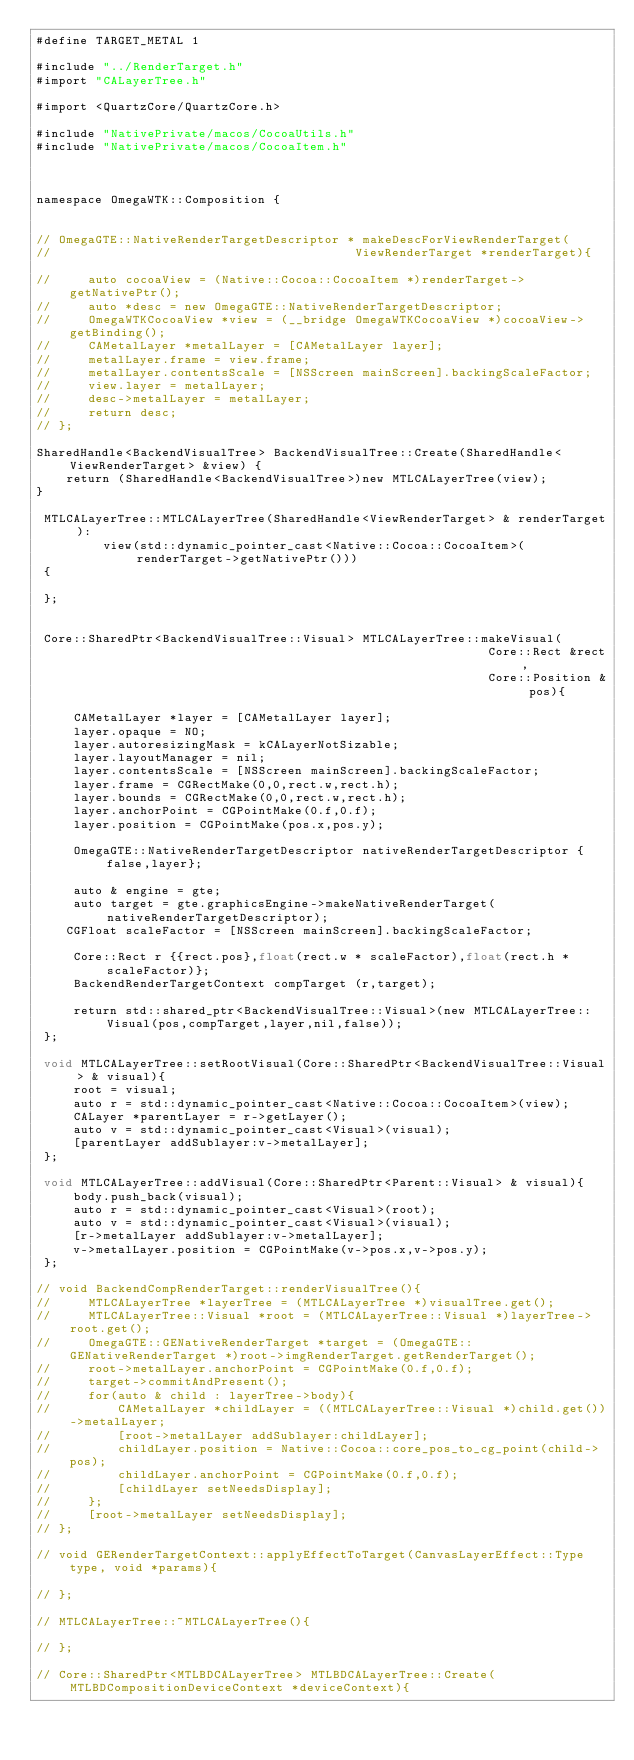<code> <loc_0><loc_0><loc_500><loc_500><_ObjectiveC_>#define TARGET_METAL 1

#include "../RenderTarget.h"
#import "CALayerTree.h"

#import <QuartzCore/QuartzCore.h>

#include "NativePrivate/macos/CocoaUtils.h"
#include "NativePrivate/macos/CocoaItem.h"



namespace OmegaWTK::Composition {


// OmegaGTE::NativeRenderTargetDescriptor * makeDescForViewRenderTarget(
//                                         ViewRenderTarget *renderTarget){

//     auto cocoaView = (Native::Cocoa::CocoaItem *)renderTarget->getNativePtr();
//     auto *desc = new OmegaGTE::NativeRenderTargetDescriptor;
//     OmegaWTKCocoaView *view = (__bridge OmegaWTKCocoaView *)cocoaView->getBinding();
//     CAMetalLayer *metalLayer = [CAMetalLayer layer];
//     metalLayer.frame = view.frame;
//     metalLayer.contentsScale = [NSScreen mainScreen].backingScaleFactor;
//     view.layer = metalLayer;
//     desc->metalLayer = metalLayer;
//     return desc;
// };

SharedHandle<BackendVisualTree> BackendVisualTree::Create(SharedHandle<ViewRenderTarget> &view) {
    return (SharedHandle<BackendVisualTree>)new MTLCALayerTree(view);
}

 MTLCALayerTree::MTLCALayerTree(SharedHandle<ViewRenderTarget> & renderTarget):
         view(std::dynamic_pointer_cast<Native::Cocoa::CocoaItem>(renderTarget->getNativePtr()))
 {

 };


 Core::SharedPtr<BackendVisualTree::Visual> MTLCALayerTree::makeVisual(
                                                             Core::Rect &rect,
                                                             Core::Position & pos){

     CAMetalLayer *layer = [CAMetalLayer layer];
     layer.opaque = NO;
     layer.autoresizingMask = kCALayerNotSizable;
     layer.layoutManager = nil;
     layer.contentsScale = [NSScreen mainScreen].backingScaleFactor;
     layer.frame = CGRectMake(0,0,rect.w,rect.h);
     layer.bounds = CGRectMake(0,0,rect.w,rect.h);
     layer.anchorPoint = CGPointMake(0.f,0.f);
     layer.position = CGPointMake(pos.x,pos.y);

     OmegaGTE::NativeRenderTargetDescriptor nativeRenderTargetDescriptor {false,layer};

     auto & engine = gte;
     auto target = gte.graphicsEngine->makeNativeRenderTarget(nativeRenderTargetDescriptor);
    CGFloat scaleFactor = [NSScreen mainScreen].backingScaleFactor;

     Core::Rect r {{rect.pos},float(rect.w * scaleFactor),float(rect.h * scaleFactor)};
     BackendRenderTargetContext compTarget (r,target);

     return std::shared_ptr<BackendVisualTree::Visual>(new MTLCALayerTree::Visual(pos,compTarget,layer,nil,false));
 };

 void MTLCALayerTree::setRootVisual(Core::SharedPtr<BackendVisualTree::Visual> & visual){
     root = visual;
     auto r = std::dynamic_pointer_cast<Native::Cocoa::CocoaItem>(view);
     CALayer *parentLayer = r->getLayer();
     auto v = std::dynamic_pointer_cast<Visual>(visual);
     [parentLayer addSublayer:v->metalLayer];
 };

 void MTLCALayerTree::addVisual(Core::SharedPtr<Parent::Visual> & visual){
     body.push_back(visual);
     auto r = std::dynamic_pointer_cast<Visual>(root);
     auto v = std::dynamic_pointer_cast<Visual>(visual);
     [r->metalLayer addSublayer:v->metalLayer];
     v->metalLayer.position = CGPointMake(v->pos.x,v->pos.y);
 };

// void BackendCompRenderTarget::renderVisualTree(){
//     MTLCALayerTree *layerTree = (MTLCALayerTree *)visualTree.get();
//     MTLCALayerTree::Visual *root = (MTLCALayerTree::Visual *)layerTree->root.get();
//     OmegaGTE::GENativeRenderTarget *target = (OmegaGTE::GENativeRenderTarget *)root->imgRenderTarget.getRenderTarget();
//     root->metalLayer.anchorPoint = CGPointMake(0.f,0.f);
//     target->commitAndPresent();
//     for(auto & child : layerTree->body){
//         CAMetalLayer *childLayer = ((MTLCALayerTree::Visual *)child.get())->metalLayer;
//         [root->metalLayer addSublayer:childLayer];
//         childLayer.position = Native::Cocoa::core_pos_to_cg_point(child->pos);
//         childLayer.anchorPoint = CGPointMake(0.f,0.f);
//         [childLayer setNeedsDisplay];
//     };
//     [root->metalLayer setNeedsDisplay];
// };

// void GERenderTargetContext::applyEffectToTarget(CanvasLayerEffect::Type type, void *params){
        
// };

// MTLCALayerTree::~MTLCALayerTree(){
    
// };

// Core::SharedPtr<MTLBDCALayerTree> MTLBDCALayerTree::Create(MTLBDCompositionDeviceContext *deviceContext){</code> 